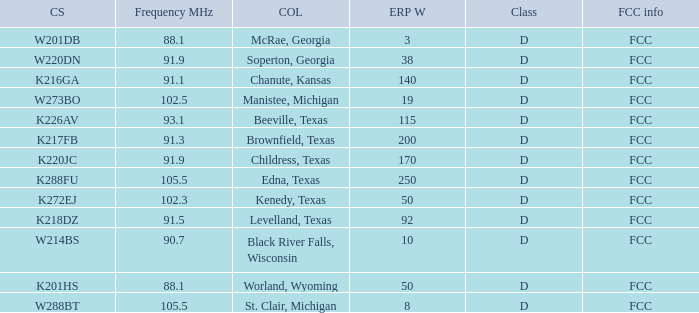What is City of License, when ERP W is greater than 3, and when Call Sign is K218DZ? Levelland, Texas. 